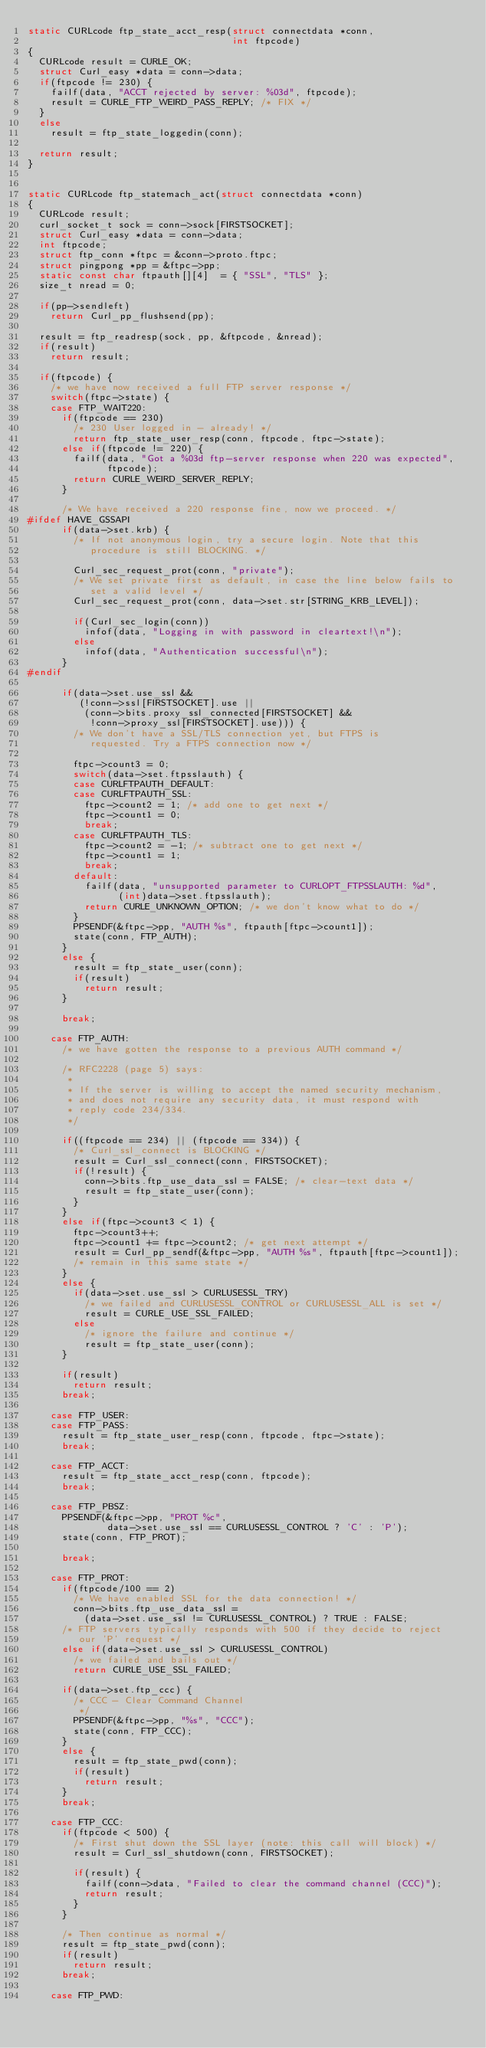<code> <loc_0><loc_0><loc_500><loc_500><_C_>static CURLcode ftp_state_acct_resp(struct connectdata *conn,
                                    int ftpcode)
{
  CURLcode result = CURLE_OK;
  struct Curl_easy *data = conn->data;
  if(ftpcode != 230) {
    failf(data, "ACCT rejected by server: %03d", ftpcode);
    result = CURLE_FTP_WEIRD_PASS_REPLY; /* FIX */
  }
  else
    result = ftp_state_loggedin(conn);

  return result;
}


static CURLcode ftp_statemach_act(struct connectdata *conn)
{
  CURLcode result;
  curl_socket_t sock = conn->sock[FIRSTSOCKET];
  struct Curl_easy *data = conn->data;
  int ftpcode;
  struct ftp_conn *ftpc = &conn->proto.ftpc;
  struct pingpong *pp = &ftpc->pp;
  static const char ftpauth[][4]  = { "SSL", "TLS" };
  size_t nread = 0;

  if(pp->sendleft)
    return Curl_pp_flushsend(pp);

  result = ftp_readresp(sock, pp, &ftpcode, &nread);
  if(result)
    return result;

  if(ftpcode) {
    /* we have now received a full FTP server response */
    switch(ftpc->state) {
    case FTP_WAIT220:
      if(ftpcode == 230)
        /* 230 User logged in - already! */
        return ftp_state_user_resp(conn, ftpcode, ftpc->state);
      else if(ftpcode != 220) {
        failf(data, "Got a %03d ftp-server response when 220 was expected",
              ftpcode);
        return CURLE_WEIRD_SERVER_REPLY;
      }

      /* We have received a 220 response fine, now we proceed. */
#ifdef HAVE_GSSAPI
      if(data->set.krb) {
        /* If not anonymous login, try a secure login. Note that this
           procedure is still BLOCKING. */

        Curl_sec_request_prot(conn, "private");
        /* We set private first as default, in case the line below fails to
           set a valid level */
        Curl_sec_request_prot(conn, data->set.str[STRING_KRB_LEVEL]);

        if(Curl_sec_login(conn))
          infof(data, "Logging in with password in cleartext!\n");
        else
          infof(data, "Authentication successful\n");
      }
#endif

      if(data->set.use_ssl &&
         (!conn->ssl[FIRSTSOCKET].use ||
          (conn->bits.proxy_ssl_connected[FIRSTSOCKET] &&
           !conn->proxy_ssl[FIRSTSOCKET].use))) {
        /* We don't have a SSL/TLS connection yet, but FTPS is
           requested. Try a FTPS connection now */

        ftpc->count3 = 0;
        switch(data->set.ftpsslauth) {
        case CURLFTPAUTH_DEFAULT:
        case CURLFTPAUTH_SSL:
          ftpc->count2 = 1; /* add one to get next */
          ftpc->count1 = 0;
          break;
        case CURLFTPAUTH_TLS:
          ftpc->count2 = -1; /* subtract one to get next */
          ftpc->count1 = 1;
          break;
        default:
          failf(data, "unsupported parameter to CURLOPT_FTPSSLAUTH: %d",
                (int)data->set.ftpsslauth);
          return CURLE_UNKNOWN_OPTION; /* we don't know what to do */
        }
        PPSENDF(&ftpc->pp, "AUTH %s", ftpauth[ftpc->count1]);
        state(conn, FTP_AUTH);
      }
      else {
        result = ftp_state_user(conn);
        if(result)
          return result;
      }

      break;

    case FTP_AUTH:
      /* we have gotten the response to a previous AUTH command */

      /* RFC2228 (page 5) says:
       *
       * If the server is willing to accept the named security mechanism,
       * and does not require any security data, it must respond with
       * reply code 234/334.
       */

      if((ftpcode == 234) || (ftpcode == 334)) {
        /* Curl_ssl_connect is BLOCKING */
        result = Curl_ssl_connect(conn, FIRSTSOCKET);
        if(!result) {
          conn->bits.ftp_use_data_ssl = FALSE; /* clear-text data */
          result = ftp_state_user(conn);
        }
      }
      else if(ftpc->count3 < 1) {
        ftpc->count3++;
        ftpc->count1 += ftpc->count2; /* get next attempt */
        result = Curl_pp_sendf(&ftpc->pp, "AUTH %s", ftpauth[ftpc->count1]);
        /* remain in this same state */
      }
      else {
        if(data->set.use_ssl > CURLUSESSL_TRY)
          /* we failed and CURLUSESSL_CONTROL or CURLUSESSL_ALL is set */
          result = CURLE_USE_SSL_FAILED;
        else
          /* ignore the failure and continue */
          result = ftp_state_user(conn);
      }

      if(result)
        return result;
      break;

    case FTP_USER:
    case FTP_PASS:
      result = ftp_state_user_resp(conn, ftpcode, ftpc->state);
      break;

    case FTP_ACCT:
      result = ftp_state_acct_resp(conn, ftpcode);
      break;

    case FTP_PBSZ:
      PPSENDF(&ftpc->pp, "PROT %c",
              data->set.use_ssl == CURLUSESSL_CONTROL ? 'C' : 'P');
      state(conn, FTP_PROT);

      break;

    case FTP_PROT:
      if(ftpcode/100 == 2)
        /* We have enabled SSL for the data connection! */
        conn->bits.ftp_use_data_ssl =
          (data->set.use_ssl != CURLUSESSL_CONTROL) ? TRUE : FALSE;
      /* FTP servers typically responds with 500 if they decide to reject
         our 'P' request */
      else if(data->set.use_ssl > CURLUSESSL_CONTROL)
        /* we failed and bails out */
        return CURLE_USE_SSL_FAILED;

      if(data->set.ftp_ccc) {
        /* CCC - Clear Command Channel
         */
        PPSENDF(&ftpc->pp, "%s", "CCC");
        state(conn, FTP_CCC);
      }
      else {
        result = ftp_state_pwd(conn);
        if(result)
          return result;
      }
      break;

    case FTP_CCC:
      if(ftpcode < 500) {
        /* First shut down the SSL layer (note: this call will block) */
        result = Curl_ssl_shutdown(conn, FIRSTSOCKET);

        if(result) {
          failf(conn->data, "Failed to clear the command channel (CCC)");
          return result;
        }
      }

      /* Then continue as normal */
      result = ftp_state_pwd(conn);
      if(result)
        return result;
      break;

    case FTP_PWD:</code> 